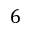Convert formula to latex. <formula><loc_0><loc_0><loc_500><loc_500>6</formula> 